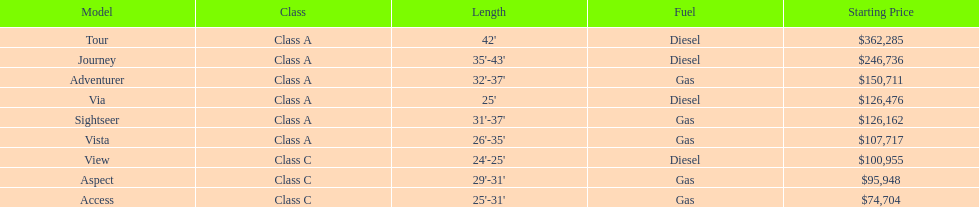What is the name of the top priced winnebago model? Tour. 